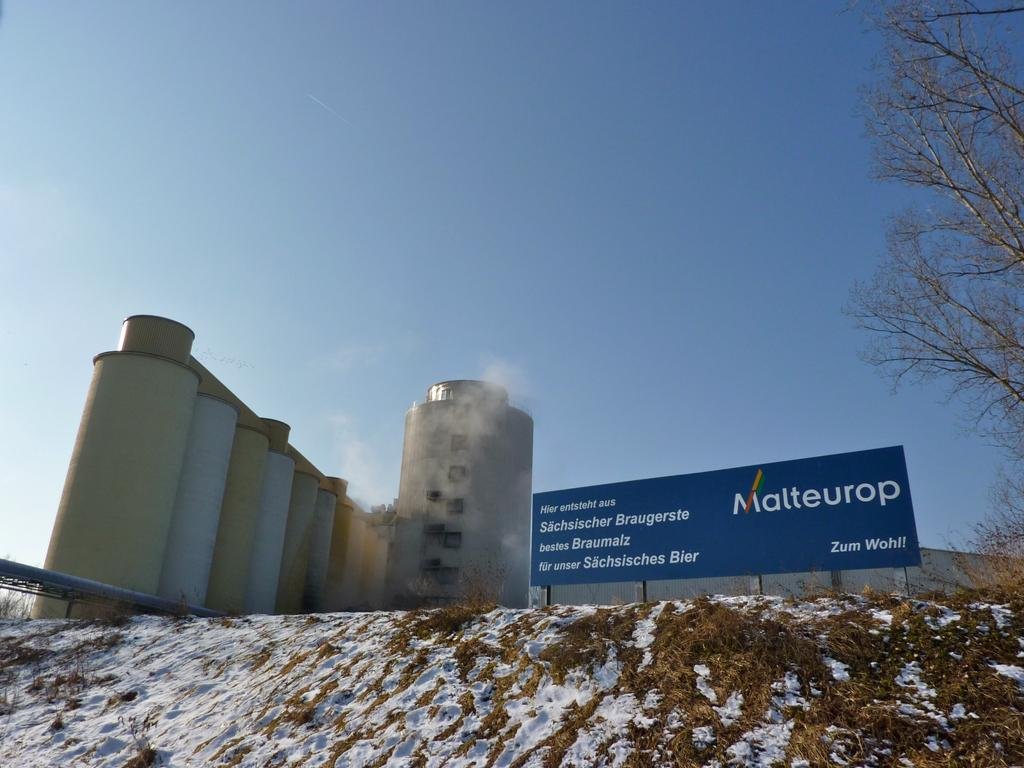<image>
Render a clear and concise summary of the photo. Large blue sign that says "ZUM WOHL" placed in the grass. 